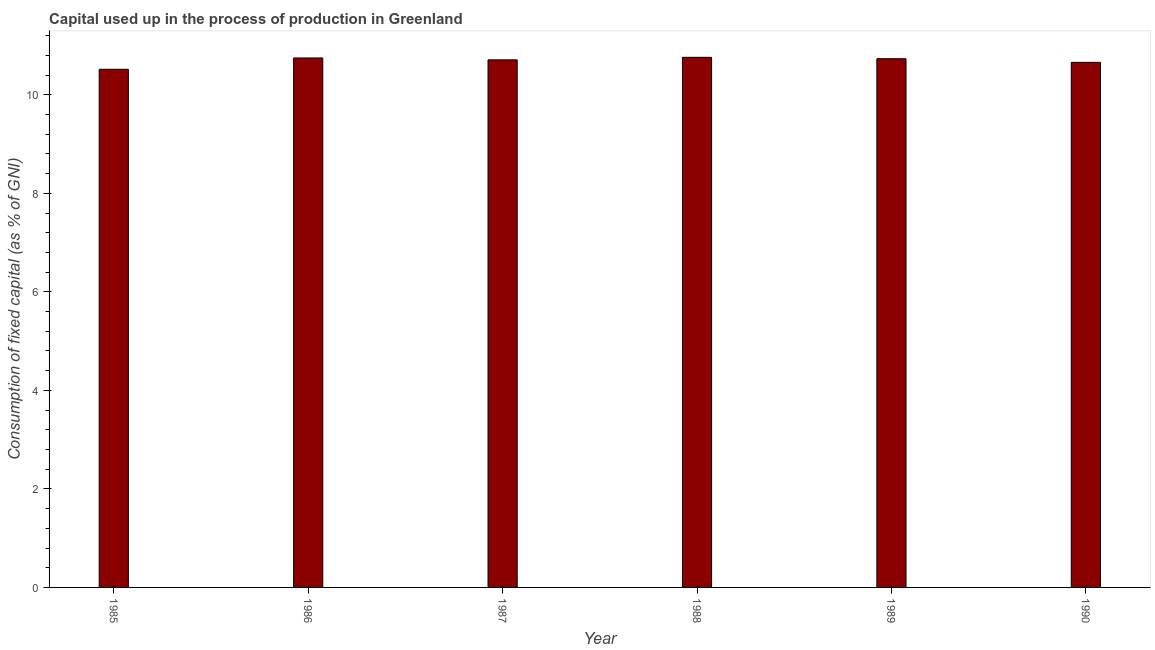What is the title of the graph?
Your answer should be very brief. Capital used up in the process of production in Greenland. What is the label or title of the Y-axis?
Your answer should be compact. Consumption of fixed capital (as % of GNI). What is the consumption of fixed capital in 1989?
Your response must be concise. 10.73. Across all years, what is the maximum consumption of fixed capital?
Keep it short and to the point. 10.76. Across all years, what is the minimum consumption of fixed capital?
Give a very brief answer. 10.52. What is the sum of the consumption of fixed capital?
Your answer should be compact. 64.13. What is the difference between the consumption of fixed capital in 1988 and 1989?
Provide a succinct answer. 0.03. What is the average consumption of fixed capital per year?
Provide a succinct answer. 10.69. What is the median consumption of fixed capital?
Your answer should be very brief. 10.72. In how many years, is the consumption of fixed capital greater than 3.6 %?
Make the answer very short. 6. Do a majority of the years between 1986 and 1988 (inclusive) have consumption of fixed capital greater than 2.4 %?
Offer a very short reply. Yes. What is the ratio of the consumption of fixed capital in 1987 to that in 1990?
Offer a very short reply. 1. What is the difference between the highest and the second highest consumption of fixed capital?
Keep it short and to the point. 0.01. Is the sum of the consumption of fixed capital in 1986 and 1988 greater than the maximum consumption of fixed capital across all years?
Ensure brevity in your answer.  Yes. What is the difference between the highest and the lowest consumption of fixed capital?
Offer a terse response. 0.24. In how many years, is the consumption of fixed capital greater than the average consumption of fixed capital taken over all years?
Ensure brevity in your answer.  4. How many years are there in the graph?
Offer a terse response. 6. What is the difference between two consecutive major ticks on the Y-axis?
Make the answer very short. 2. Are the values on the major ticks of Y-axis written in scientific E-notation?
Keep it short and to the point. No. What is the Consumption of fixed capital (as % of GNI) in 1985?
Offer a terse response. 10.52. What is the Consumption of fixed capital (as % of GNI) of 1986?
Provide a short and direct response. 10.75. What is the Consumption of fixed capital (as % of GNI) in 1987?
Ensure brevity in your answer.  10.71. What is the Consumption of fixed capital (as % of GNI) of 1988?
Offer a terse response. 10.76. What is the Consumption of fixed capital (as % of GNI) of 1989?
Offer a terse response. 10.73. What is the Consumption of fixed capital (as % of GNI) of 1990?
Provide a succinct answer. 10.66. What is the difference between the Consumption of fixed capital (as % of GNI) in 1985 and 1986?
Keep it short and to the point. -0.23. What is the difference between the Consumption of fixed capital (as % of GNI) in 1985 and 1987?
Your answer should be compact. -0.19. What is the difference between the Consumption of fixed capital (as % of GNI) in 1985 and 1988?
Your answer should be very brief. -0.24. What is the difference between the Consumption of fixed capital (as % of GNI) in 1985 and 1989?
Your answer should be compact. -0.21. What is the difference between the Consumption of fixed capital (as % of GNI) in 1985 and 1990?
Your answer should be compact. -0.14. What is the difference between the Consumption of fixed capital (as % of GNI) in 1986 and 1987?
Your answer should be very brief. 0.04. What is the difference between the Consumption of fixed capital (as % of GNI) in 1986 and 1988?
Offer a terse response. -0.01. What is the difference between the Consumption of fixed capital (as % of GNI) in 1986 and 1989?
Your response must be concise. 0.02. What is the difference between the Consumption of fixed capital (as % of GNI) in 1986 and 1990?
Make the answer very short. 0.09. What is the difference between the Consumption of fixed capital (as % of GNI) in 1987 and 1988?
Keep it short and to the point. -0.05. What is the difference between the Consumption of fixed capital (as % of GNI) in 1987 and 1989?
Keep it short and to the point. -0.02. What is the difference between the Consumption of fixed capital (as % of GNI) in 1987 and 1990?
Your response must be concise. 0.05. What is the difference between the Consumption of fixed capital (as % of GNI) in 1988 and 1989?
Make the answer very short. 0.03. What is the difference between the Consumption of fixed capital (as % of GNI) in 1988 and 1990?
Give a very brief answer. 0.1. What is the difference between the Consumption of fixed capital (as % of GNI) in 1989 and 1990?
Your response must be concise. 0.07. What is the ratio of the Consumption of fixed capital (as % of GNI) in 1985 to that in 1986?
Your answer should be very brief. 0.98. What is the ratio of the Consumption of fixed capital (as % of GNI) in 1985 to that in 1988?
Offer a very short reply. 0.98. What is the ratio of the Consumption of fixed capital (as % of GNI) in 1985 to that in 1989?
Your response must be concise. 0.98. What is the ratio of the Consumption of fixed capital (as % of GNI) in 1985 to that in 1990?
Give a very brief answer. 0.99. What is the ratio of the Consumption of fixed capital (as % of GNI) in 1986 to that in 1989?
Give a very brief answer. 1. What is the ratio of the Consumption of fixed capital (as % of GNI) in 1986 to that in 1990?
Provide a short and direct response. 1.01. What is the ratio of the Consumption of fixed capital (as % of GNI) in 1987 to that in 1988?
Provide a succinct answer. 0.99. What is the ratio of the Consumption of fixed capital (as % of GNI) in 1987 to that in 1989?
Ensure brevity in your answer.  1. What is the ratio of the Consumption of fixed capital (as % of GNI) in 1987 to that in 1990?
Give a very brief answer. 1. What is the ratio of the Consumption of fixed capital (as % of GNI) in 1989 to that in 1990?
Your answer should be compact. 1.01. 